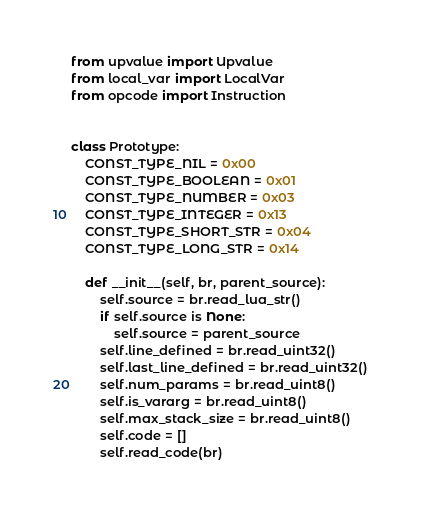Convert code to text. <code><loc_0><loc_0><loc_500><loc_500><_Python_>from upvalue import Upvalue
from local_var import LocalVar
from opcode import Instruction


class Prototype:
    CONST_TYPE_NIL = 0x00
    CONST_TYPE_BOOLEAN = 0x01
    CONST_TYPE_NUMBER = 0x03
    CONST_TYPE_INTEGER = 0x13
    CONST_TYPE_SHORT_STR = 0x04
    CONST_TYPE_LONG_STR = 0x14

    def __init__(self, br, parent_source):
        self.source = br.read_lua_str()
        if self.source is None:
            self.source = parent_source
        self.line_defined = br.read_uint32()
        self.last_line_defined = br.read_uint32()
        self.num_params = br.read_uint8()
        self.is_vararg = br.read_uint8()
        self.max_stack_size = br.read_uint8()
        self.code = []
        self.read_code(br)</code> 